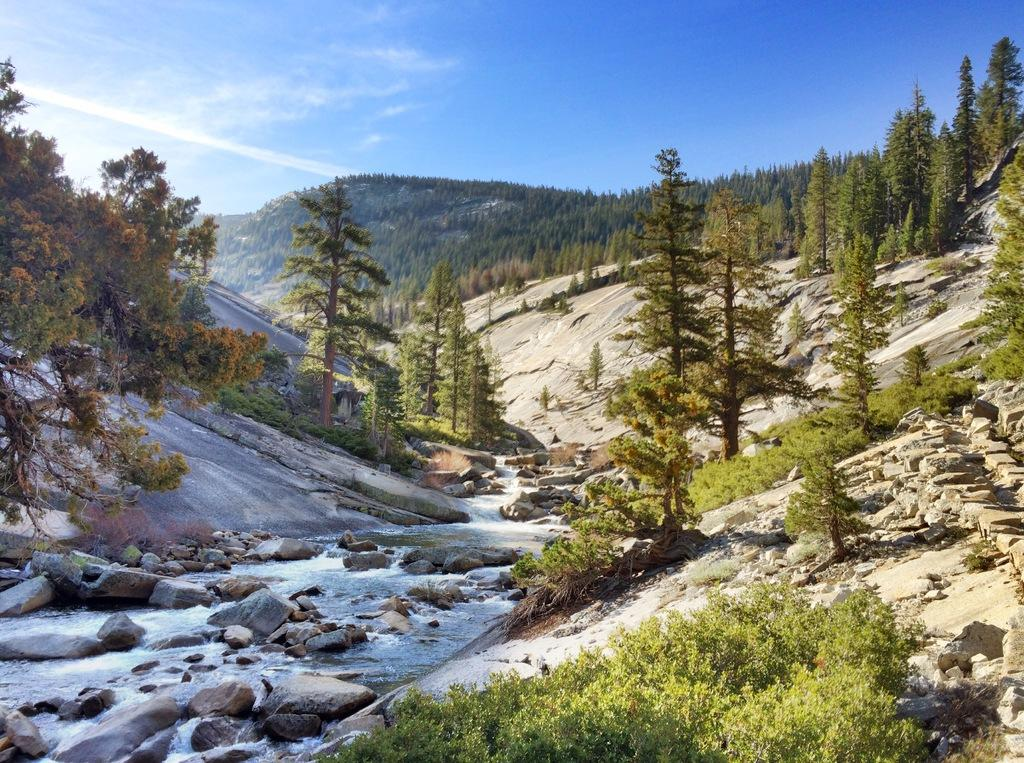What type of natural elements can be seen in the image? There are trees and rocks in the image. What is the color of the sky in the image? The sky is blue in the image. What is the unusual element present in the image? There is ice in the image. What type of vegetable is growing on the rocks in the image? There are no vegetables present in the image; it features trees, rocks, ice, and a blue sky. 